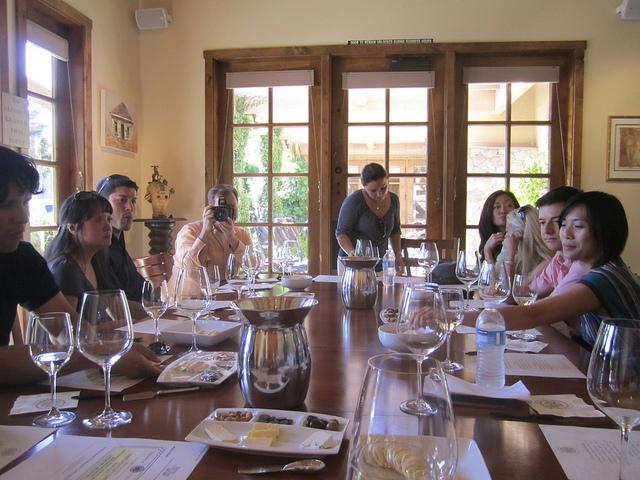Is the table set?
Write a very short answer. Yes. How many people are pictured?
Quick response, please. 9. What are these people sampling?
Quick response, please. Wine. Is this a family gathering?
Keep it brief. Yes. Are they all looking at their menus?
Keep it brief. No. How many glasses are on the table?
Give a very brief answer. 12. 